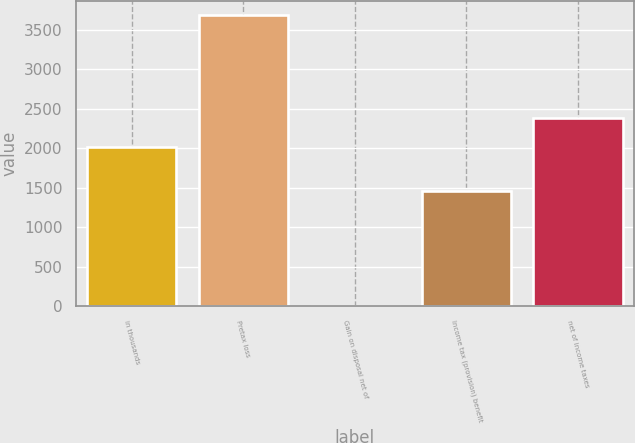Convert chart to OTSL. <chart><loc_0><loc_0><loc_500><loc_500><bar_chart><fcel>in thousands<fcel>Pretax loss<fcel>Gain on disposal net of<fcel>Income tax (provision) benefit<fcel>net of income taxes<nl><fcel>2014<fcel>3683<fcel>2.24<fcel>1460<fcel>2382.08<nl></chart> 